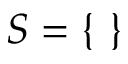Convert formula to latex. <formula><loc_0><loc_0><loc_500><loc_500>S = \{ \ \}</formula> 